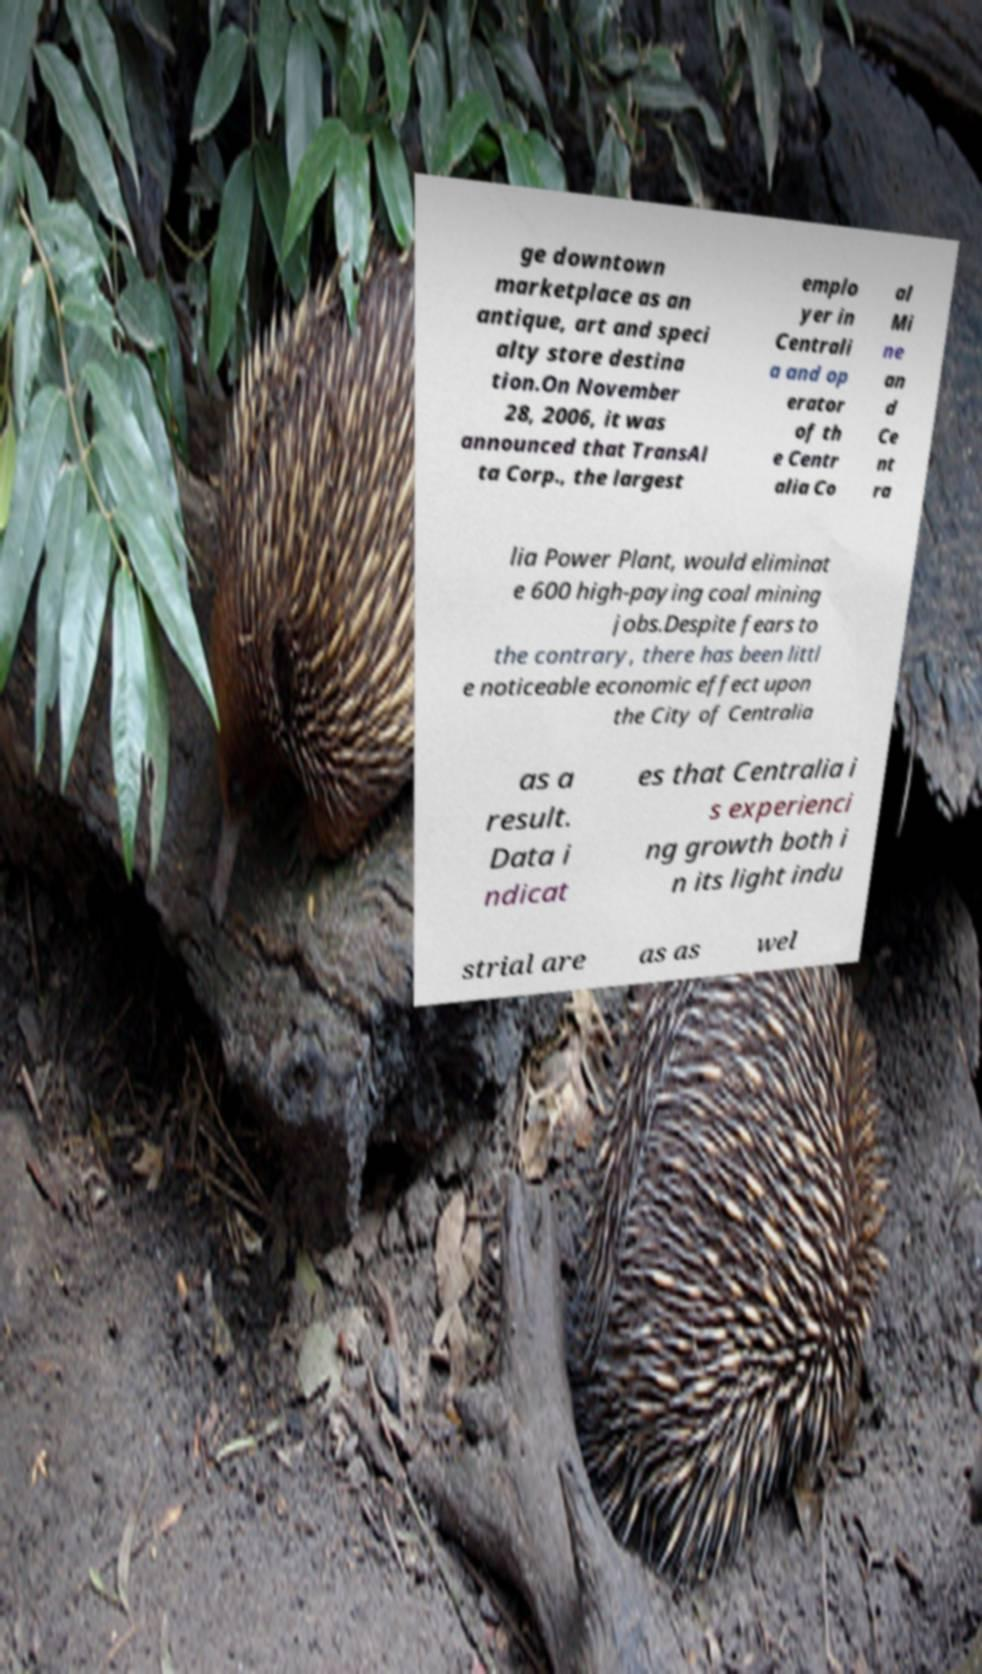What messages or text are displayed in this image? I need them in a readable, typed format. ge downtown marketplace as an antique, art and speci alty store destina tion.On November 28, 2006, it was announced that TransAl ta Corp., the largest emplo yer in Centrali a and op erator of th e Centr alia Co al Mi ne an d Ce nt ra lia Power Plant, would eliminat e 600 high-paying coal mining jobs.Despite fears to the contrary, there has been littl e noticeable economic effect upon the City of Centralia as a result. Data i ndicat es that Centralia i s experienci ng growth both i n its light indu strial are as as wel 